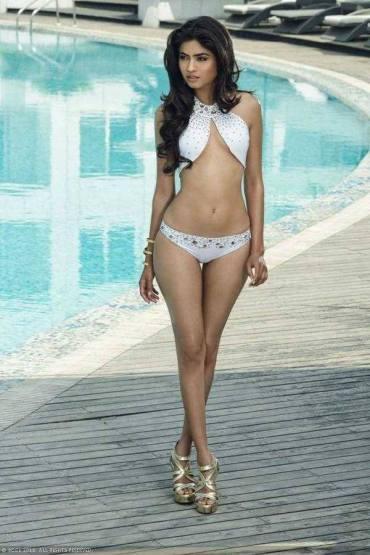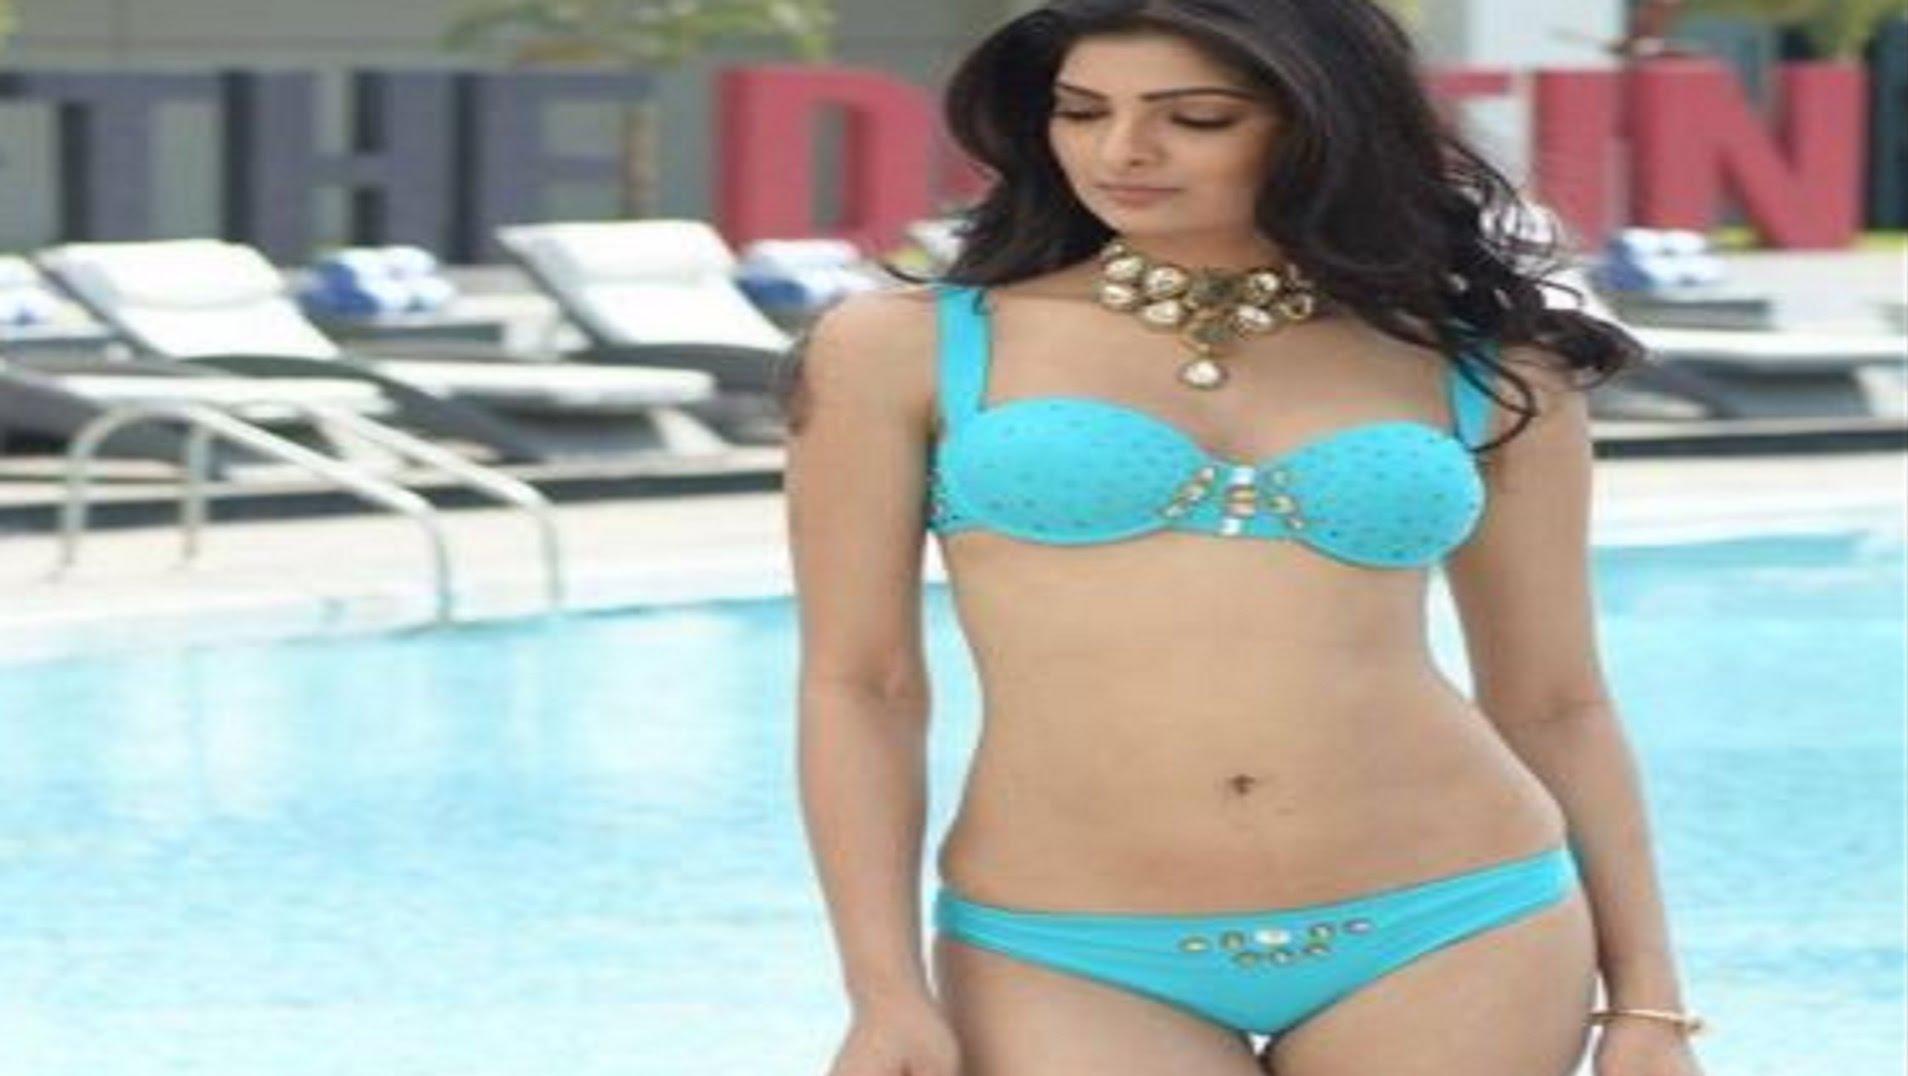The first image is the image on the left, the second image is the image on the right. Examine the images to the left and right. Is the description "A woman is touching her hair." accurate? Answer yes or no. No. The first image is the image on the left, the second image is the image on the right. For the images shown, is this caption "An image shows a standing model in a teal bikini with her long black hair swept to the right side and her gaze aimed rightward." true? Answer yes or no. No. 